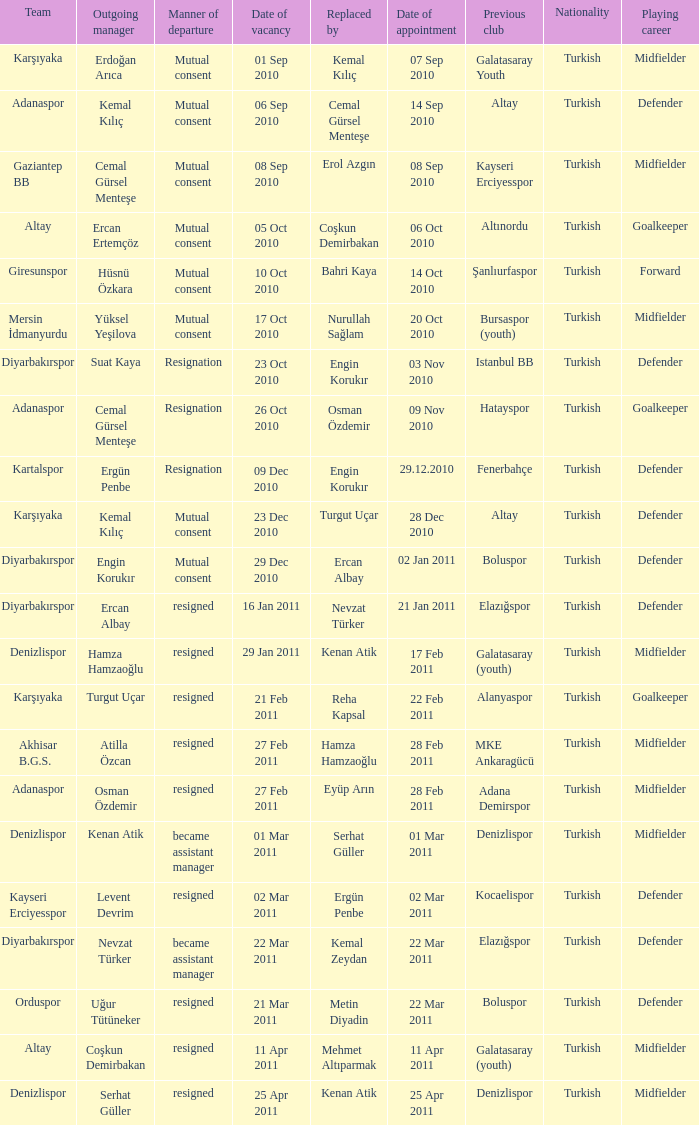Which team replaced their manager with Serhat Güller? Denizlispor. 